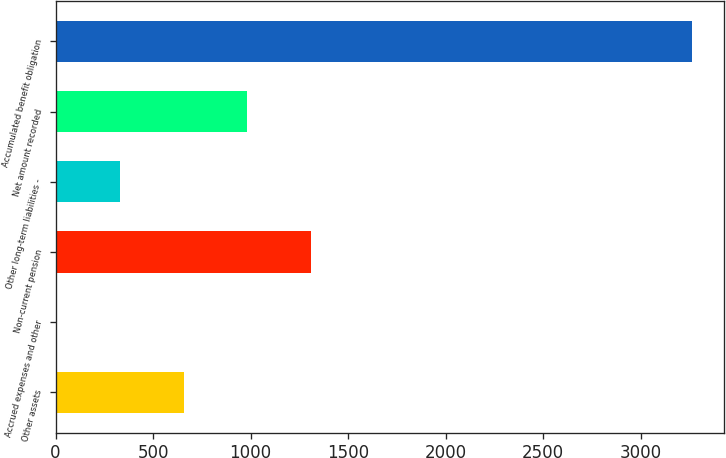Convert chart to OTSL. <chart><loc_0><loc_0><loc_500><loc_500><bar_chart><fcel>Other assets<fcel>Accrued expenses and other<fcel>Non-current pension<fcel>Other long-term liabilities -<fcel>Net amount recorded<fcel>Accumulated benefit obligation<nl><fcel>658<fcel>7<fcel>1309<fcel>332.5<fcel>983.5<fcel>3262<nl></chart> 